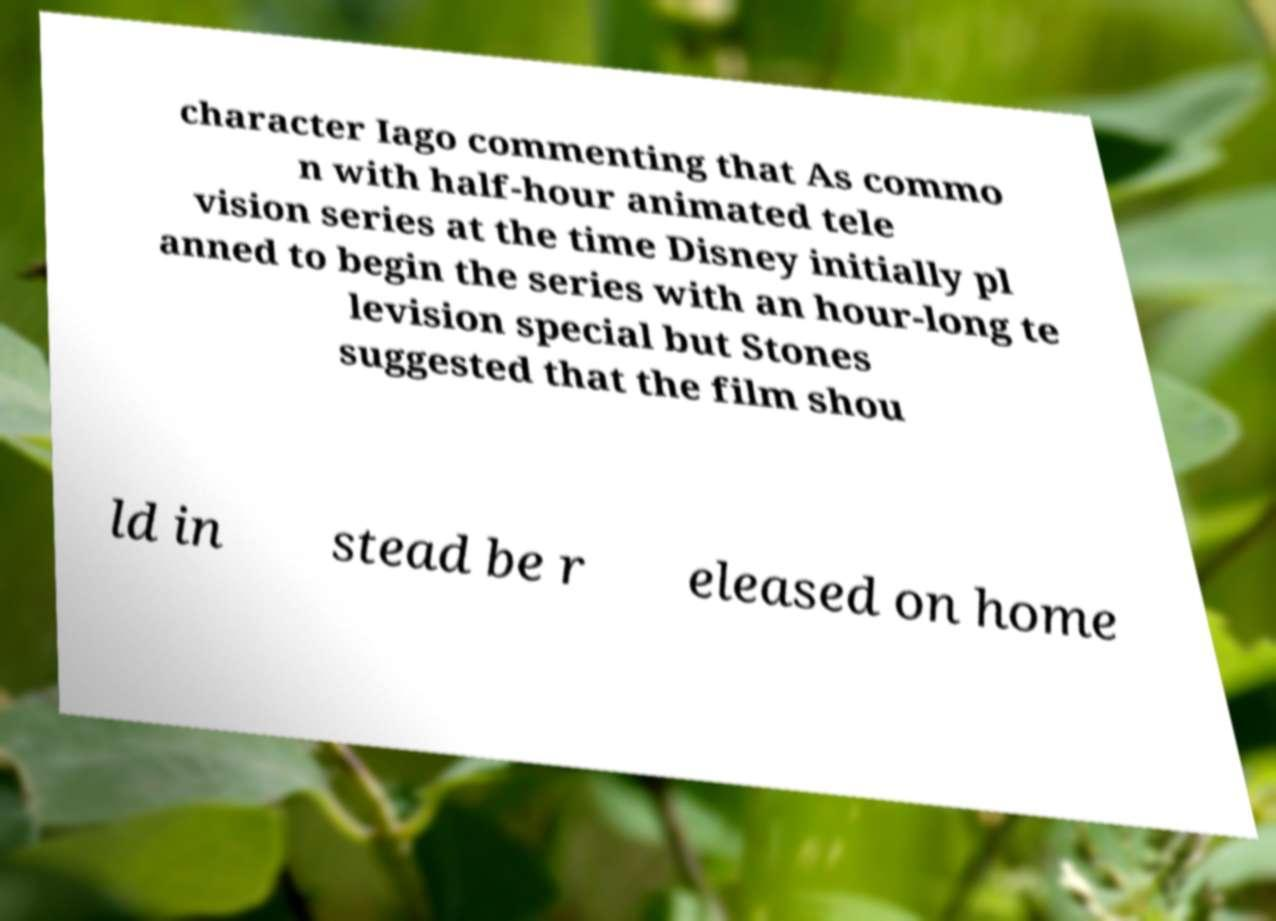What messages or text are displayed in this image? I need them in a readable, typed format. character Iago commenting that As commo n with half-hour animated tele vision series at the time Disney initially pl anned to begin the series with an hour-long te levision special but Stones suggested that the film shou ld in stead be r eleased on home 